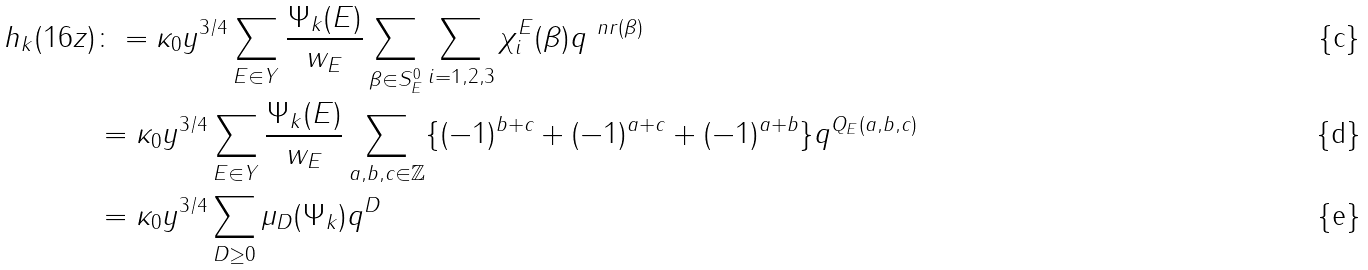<formula> <loc_0><loc_0><loc_500><loc_500>h _ { k } ( 1 6 z ) & \colon = \kappa _ { 0 } y ^ { 3 / 4 } \sum _ { E \in Y } \frac { \Psi _ { k } ( E ) } { w _ { E } } \sum _ { \beta \in S _ { E } ^ { 0 } } \sum _ { i = 1 , 2 , 3 } \chi _ { i } ^ { E } ( \beta ) q ^ { \ n r ( \beta ) } \\ & = \kappa _ { 0 } y ^ { 3 / 4 } \sum _ { E \in Y } \frac { \Psi _ { k } ( E ) } { w _ { E } } \sum _ { a , b , c \in \mathbb { Z } } \{ ( - 1 ) ^ { b + c } + ( - 1 ) ^ { a + c } + ( - 1 ) ^ { a + b } \} q ^ { Q _ { E } ( a , b , c ) } \\ & = \kappa _ { 0 } y ^ { 3 / 4 } \sum _ { D \geq 0 } \mu _ { D } ( \Psi _ { k } ) q ^ { D }</formula> 